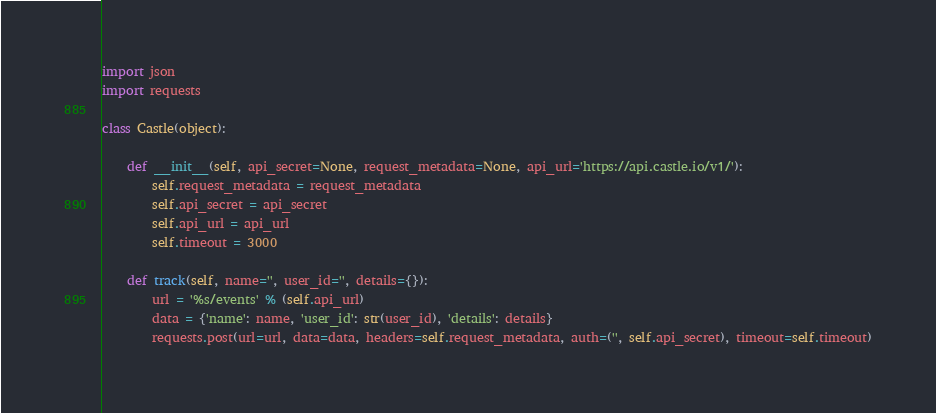<code> <loc_0><loc_0><loc_500><loc_500><_Python_>import json
import requests

class Castle(object):

    def __init__(self, api_secret=None, request_metadata=None, api_url='https://api.castle.io/v1/'):
        self.request_metadata = request_metadata
        self.api_secret = api_secret
        self.api_url = api_url
        self.timeout = 3000

    def track(self, name='', user_id='', details={}):
        url = '%s/events' % (self.api_url)
        data = {'name': name, 'user_id': str(user_id), 'details': details}
        requests.post(url=url, data=data, headers=self.request_metadata, auth=('', self.api_secret), timeout=self.timeout)
</code> 